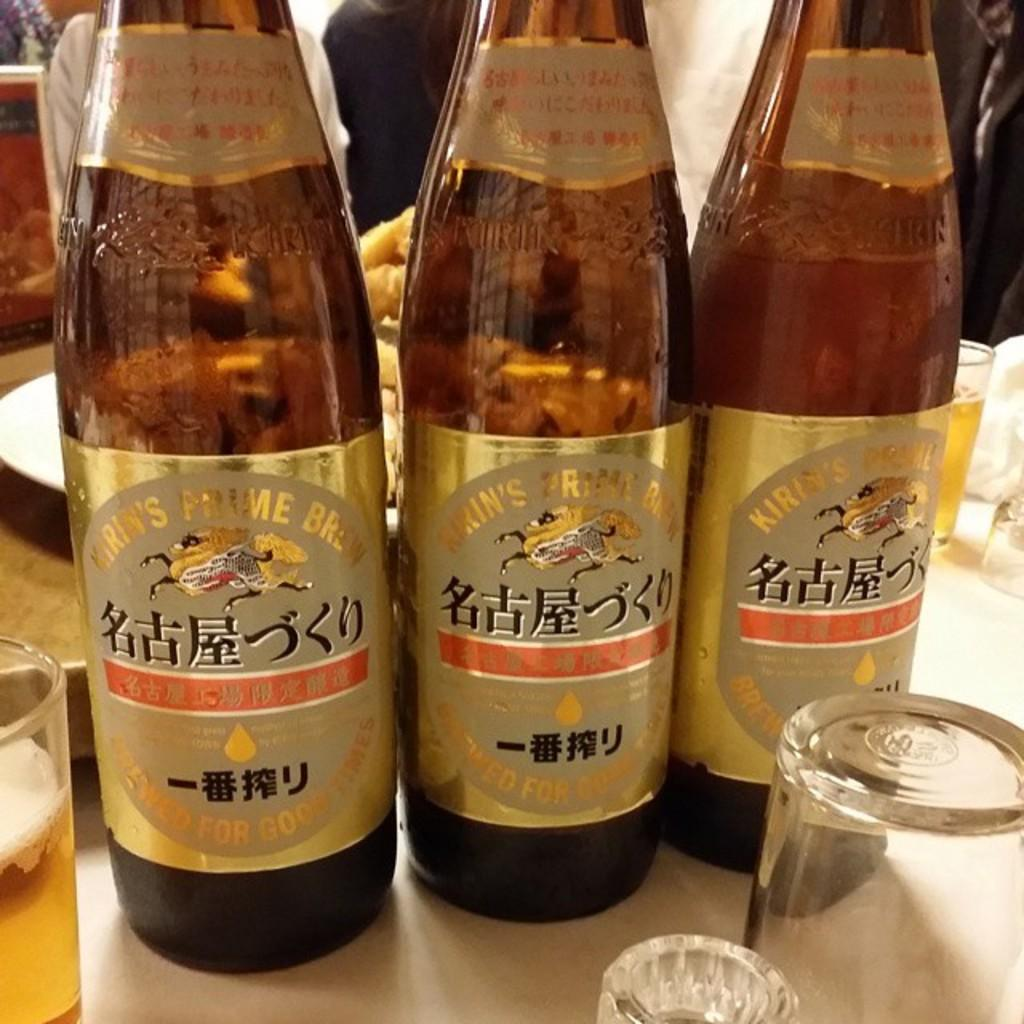<image>
Render a clear and concise summary of the photo. Three glass bottles of Kiran's Prime Brew are lined up on a table. 